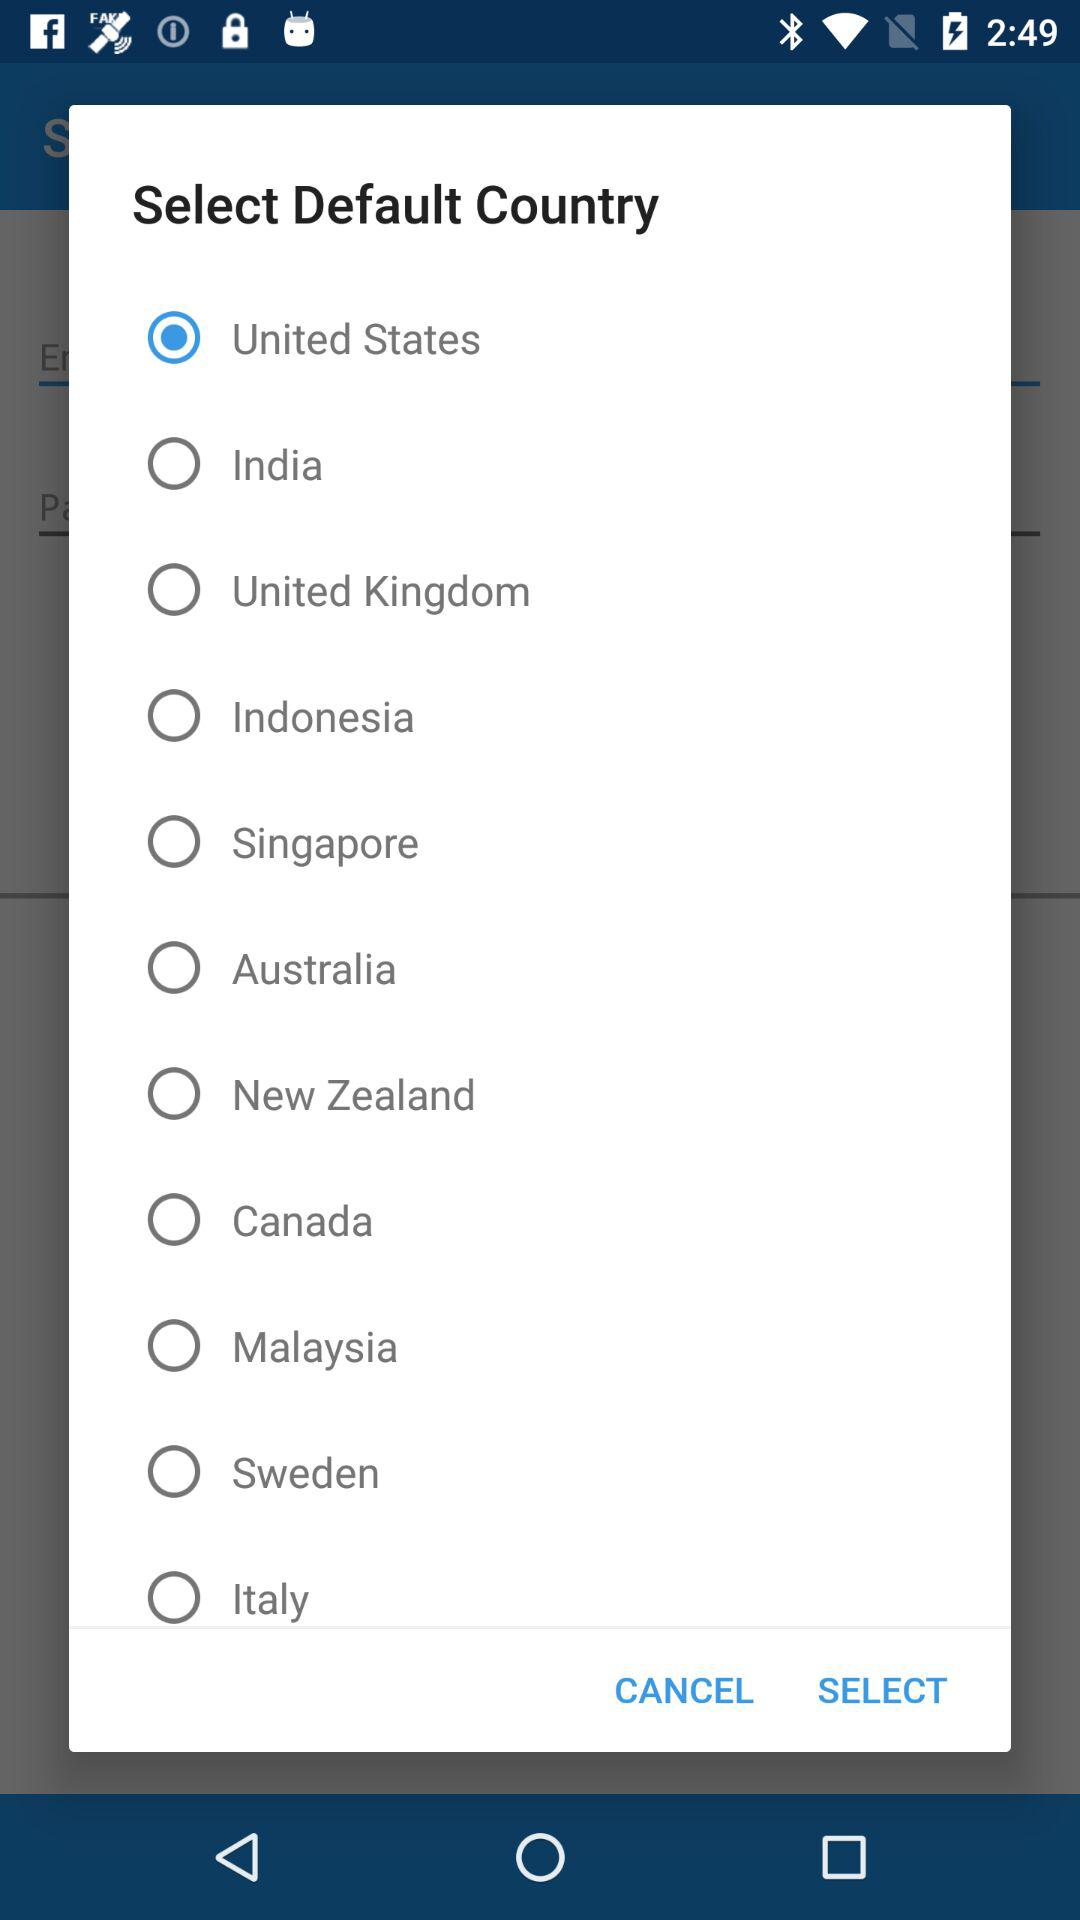Which country is selected? The selected country is the United States. 